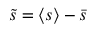Convert formula to latex. <formula><loc_0><loc_0><loc_500><loc_500>\tilde { s } = \langle s \rangle - \bar { s }</formula> 